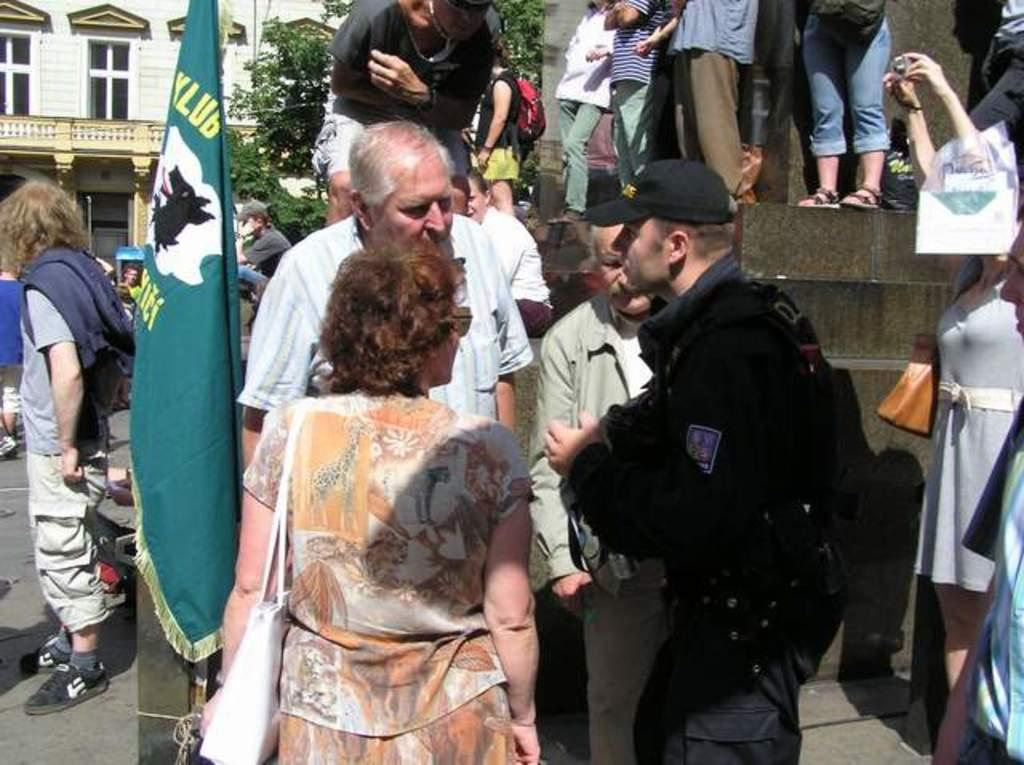What are the people in the image doing? There are people doing different activities in the image. Where is the flag located in the image? The flag is on the left side of the image. What can be seen in the background of the image? There is a building and a tree in the background of the image. What type of humor can be seen in the image? There is no humor present in the image. --- Facts: 1. There is a car in the image. 2. The car is red. 3. The car has four doors. 4. The car is parked on the street. Absurd Topics: unicorn, rainbow, magic wand Conversation: What is the main subject in the image? The main subject in the image is a car. What color is the car? The car is red. How many doors does the car have? The car has four doors. Where is the car located in the image? The car is parked on the street. Reasoning: Let's think step by step in order to produce the conversation. We start by identifying the main subject of the image, which is a car. Next, we describe specific features of the car, such as its color (red) and the number of doors (four). Then, we observe the location of the car in the image, which is parked on the street. Absurd Question/Answer: Can you see a unicorn in the image? No, there is no unicorn present in the image. --- Facts: 1. There is a group of people in the image. 2. The people are wearing hats. 3. The people are holding hands. 4. The people are standing in a circle. Absurd Topics: flying saucer, alien creature, space suit Conversation: How many people are in the image? There is a group of people in the image. What are the people wearing on their heads? The people are wearing hats. What are the people doing with their hands? The people are holding hands. How are the people positioned in the image? The people are standing in a circle. Reasoning: Let's think step by step in order to produce the conversation. We start by identifying the main subjects of the image, which are a group of people. Next, we describe specific features of the people, such as their attire (hats) and their hand positions (holding hands). Then, we observe the location and arrangement of the people in the image, which is standing in a circle. Absurd Question/Answer: Can you see a flying saucer in the image? No, there is no flying saucer present in the image. 